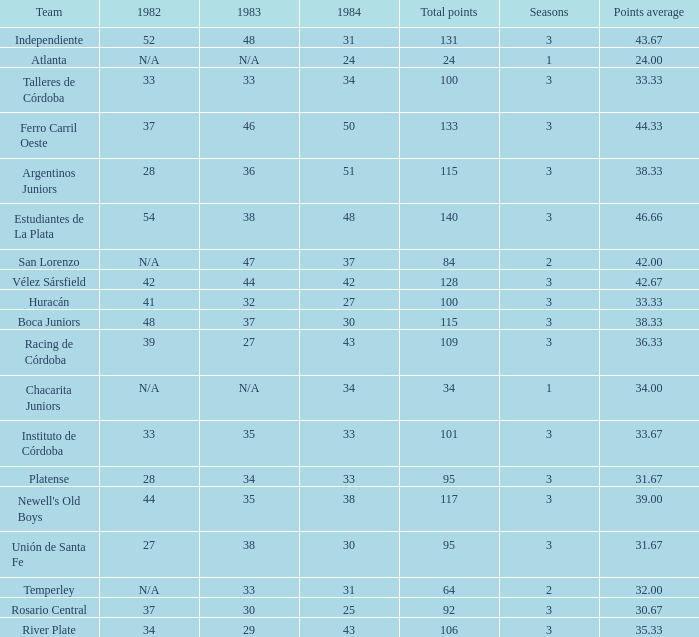What is the points total for the team with points average more than 34, 1984 score more than 37 and N/A in 1982? 0.0. 